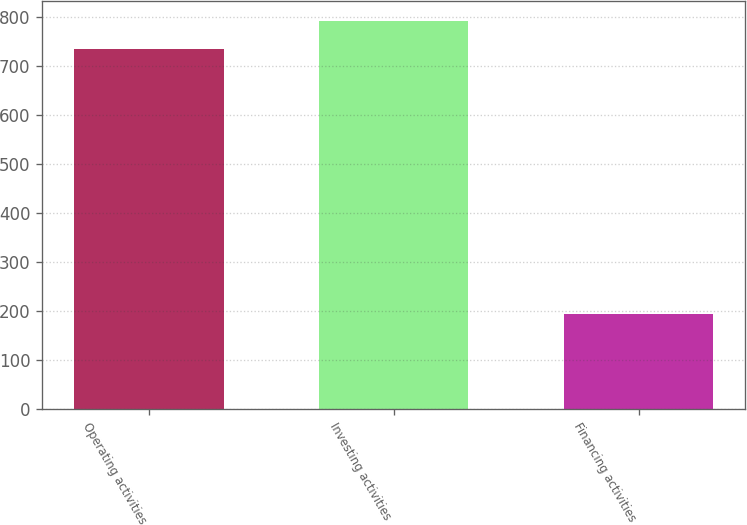<chart> <loc_0><loc_0><loc_500><loc_500><bar_chart><fcel>Operating activities<fcel>Investing activities<fcel>Financing activities<nl><fcel>733<fcel>791.5<fcel>193<nl></chart> 